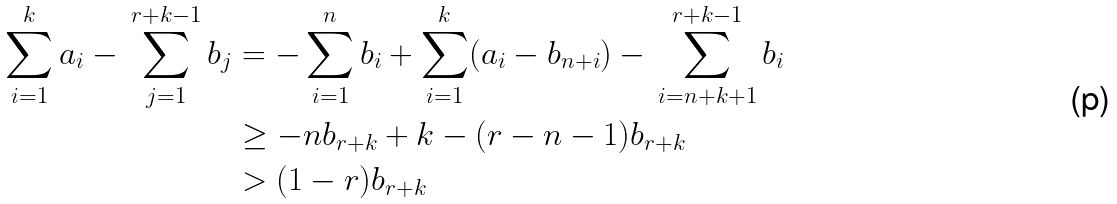Convert formula to latex. <formula><loc_0><loc_0><loc_500><loc_500>\sum _ { i = 1 } ^ { k } a _ { i } - \, \sum _ { j = 1 } ^ { r + k - 1 } b _ { j } & = - \sum _ { i = 1 } ^ { n } b _ { i } + \sum _ { i = 1 } ^ { k } ( a _ { i } - b _ { n + i } ) - \, \sum _ { i = n + k + 1 } ^ { r + k - 1 } b _ { i } \\ & \geq - n b _ { r + k } + k - ( r - n - 1 ) b _ { r + k } \\ & > ( 1 - r ) b _ { r + k }</formula> 